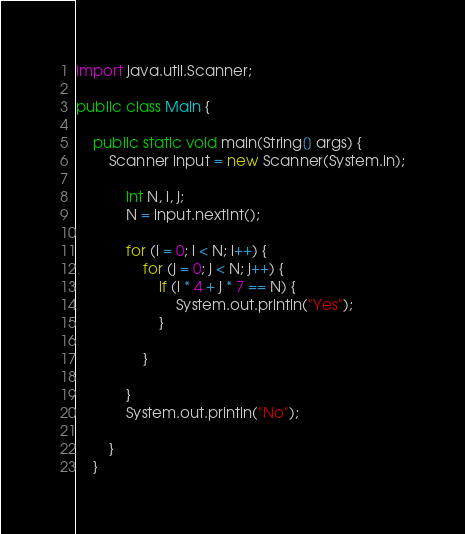Convert code to text. <code><loc_0><loc_0><loc_500><loc_500><_Java_>import java.util.Scanner;

public class Main {

    public static void main(String[] args) {
        Scanner input = new Scanner(System.in);
        
            int N, i, j;
            N = input.nextInt();

            for (i = 0; i < N; i++) {
                for (j = 0; j < N; j++) {
                    if (i * 4 + j * 7 == N) {
                        System.out.println("Yes");
                    }

                }

            }
            System.out.println("No");

        }
    }
</code> 